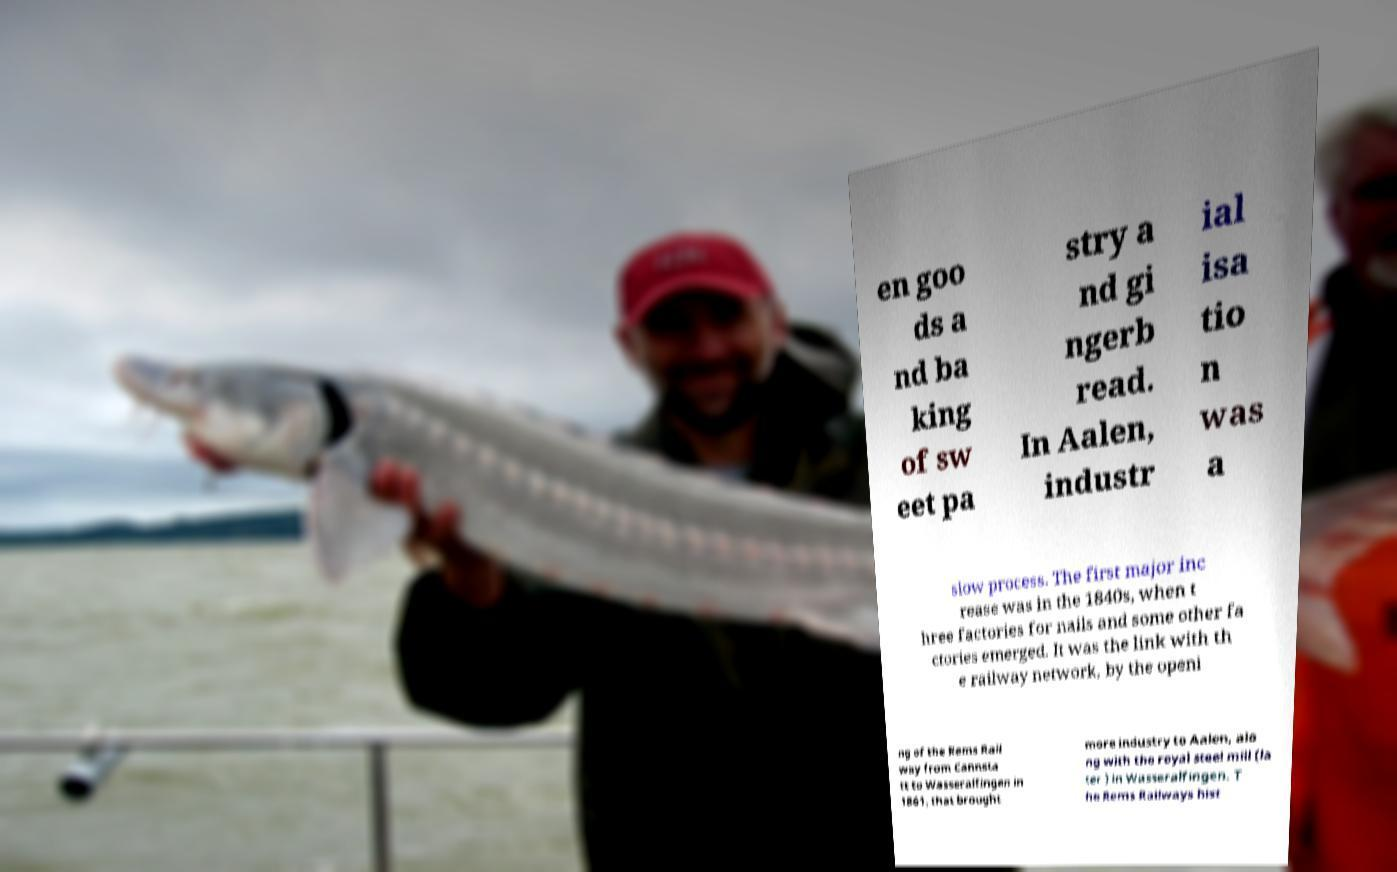I need the written content from this picture converted into text. Can you do that? en goo ds a nd ba king of sw eet pa stry a nd gi ngerb read. In Aalen, industr ial isa tio n was a slow process. The first major inc rease was in the 1840s, when t hree factories for nails and some other fa ctories emerged. It was the link with th e railway network, by the openi ng of the Rems Rail way from Cannsta tt to Wasseralfingen in 1861, that brought more industry to Aalen, alo ng with the royal steel mill (la ter ) in Wasseralfingen. T he Rems Railways hist 